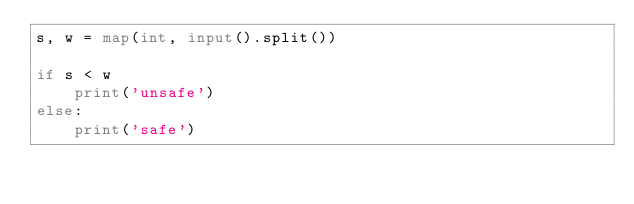<code> <loc_0><loc_0><loc_500><loc_500><_Python_>s, w = map(int, input().split())

if s < w
    print('unsafe')
else:
    print('safe')</code> 